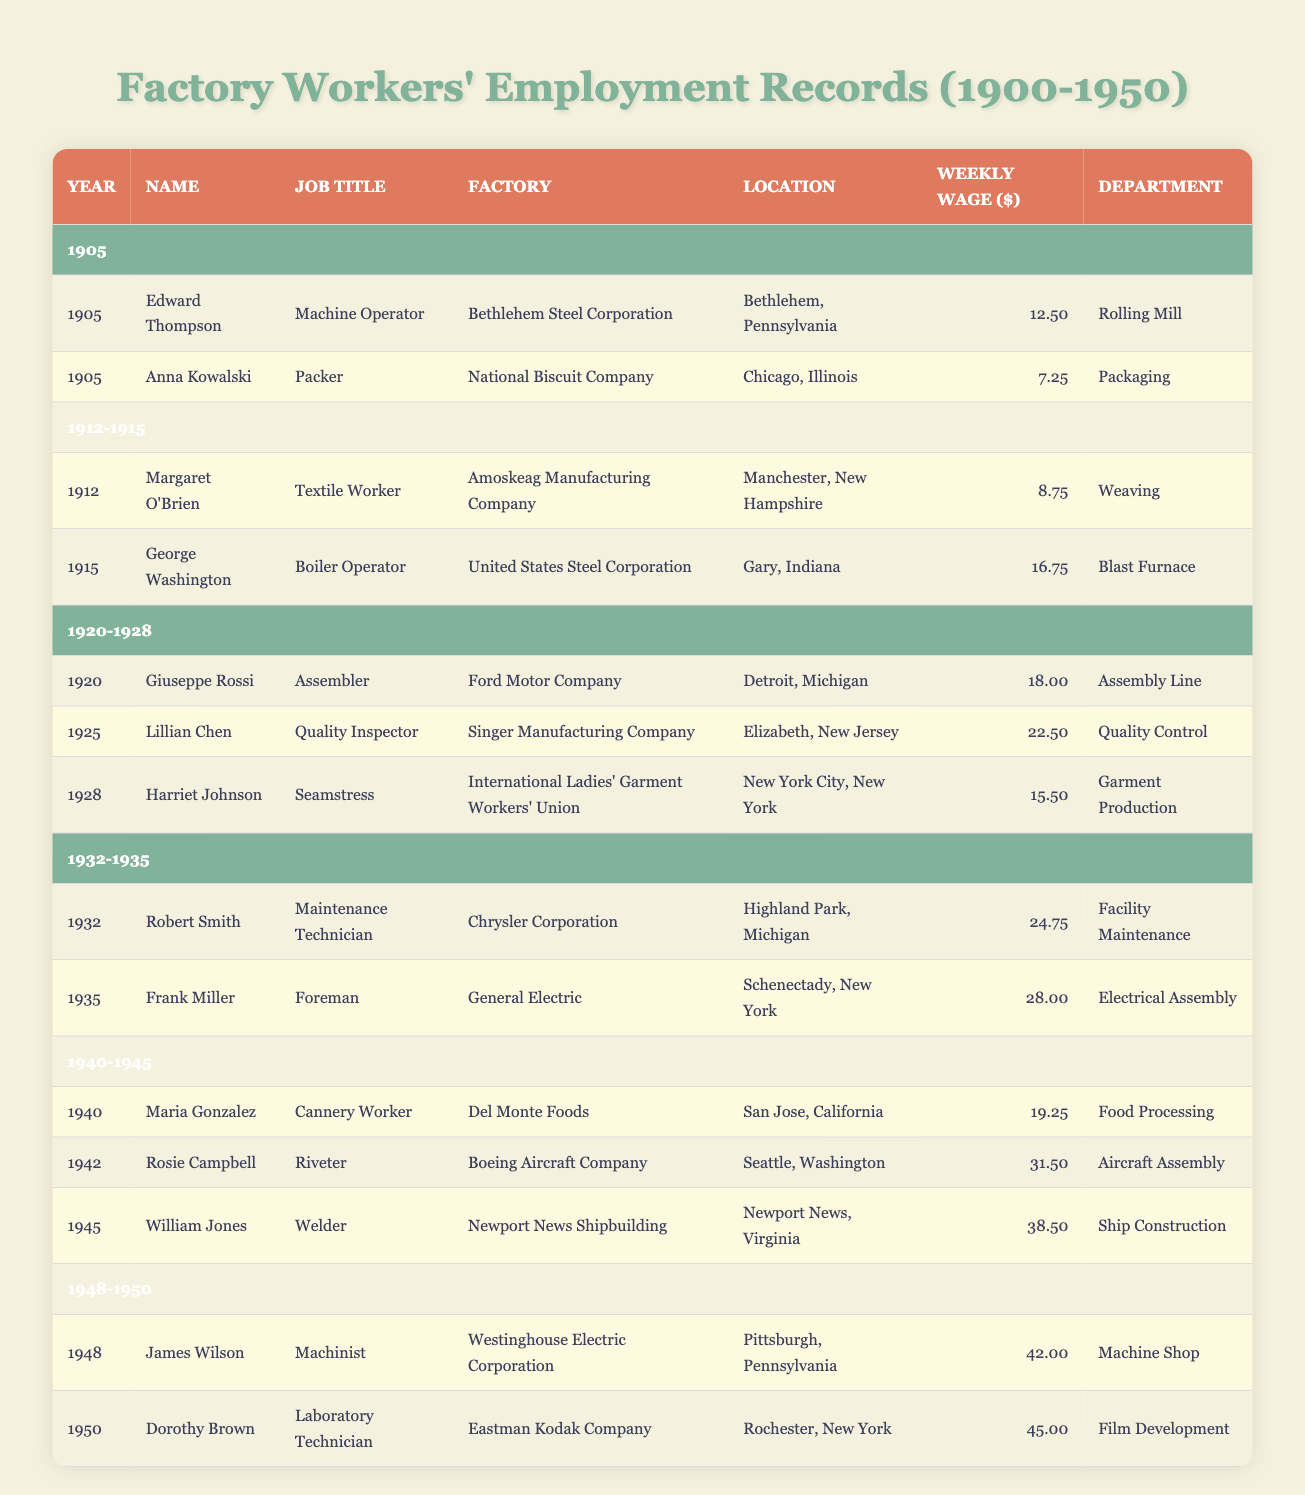What was the weekly wage of Edward Thompson? Edward Thompson is listed under the year 1905 in the table, and his weekly wage is specified as 12.50.
Answer: 12.50 Which factory did Harriet Johnson work for? The table indicates that Harriet Johnson worked for the "International Ladies' Garment Workers' Union" as noted in the row corresponding to the year 1928.
Answer: International Ladies' Garment Workers' Union What is the average weekly wage for the year 1940? In the year 1940, the weekly wage for Maria Gonzalez is 19.25. There is only one entry for 1940, so the average is the same as the wage: 19.25.
Answer: 19.25 Did any workers earn a weekly wage of 45 or more dollars? Looking through the table, Dorothy Brown earns 45.00 in 1950, which confirms that at least one worker earned 45 dollars or more weekly.
Answer: Yes Which job titles correspond to the highest wages listed? First, we locate the wages in the table: James Wilson is a Machinist at 42.00 and Dorothy Brown is a Laboratory Technician at 45.00 in 1950. Since 45.00 is the highest, the job title of Dorothy Brown corresponds to the highest wage.
Answer: Laboratory Technician What is the total weekly wage of all workers listed in the year 1935? For 1935, only Frank Miller is listed, earning 28.00. Since there is only one worker recorded in 1935, the total wage is simply his wage: 28.00.
Answer: 28.00 How does the wage of a Boiler Operator compare to that of a Machine Operator? According to the table, the weekly wage for George Washington, the Boiler Operator in 1915, is 16.75 whereas Edward Thompson, the Machine Operator in 1905, earns 12.50. So, the Boiler Operator earns more than the Machine Operator.
Answer: The Boiler Operator earns more Identify the department with the highest wage recorded in the table. To find the highest wage, we review all the weekly wages: 12.50, 8.75, 18.00, 15.50, 28.00, 31.50, 42.00, 7.25, 16.75, 22.50, 24.75, 19.25, 38.50, and 45.00. The highest wage is 45.00 for the Film Development department, where Dorothy Brown worked.
Answer: Film Development Was there a change in job titles from the beginning to the end of the timeframe mentioned? Looking at the job titles in the first year (1905) and the last (1950), we see that in 1905 the job titles include "Machine Operator" and "Packer," while in 1950, we see "Laboratory Technician." Therefore, yes, there was a change in job titles throughout this period.
Answer: Yes 